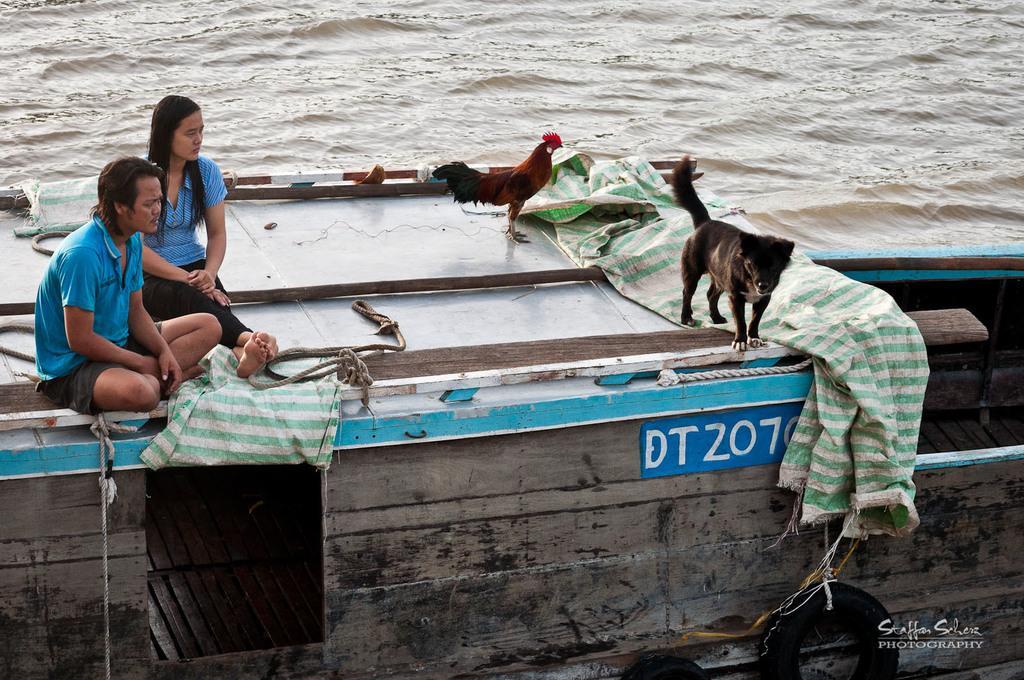How would you summarize this image in a sentence or two? In this picture there are two people sitting on a boat and we can see hen, dog, ropes, sheets and objects. In the background of the image we can see water. In the bottom right side of the image we can see text. 